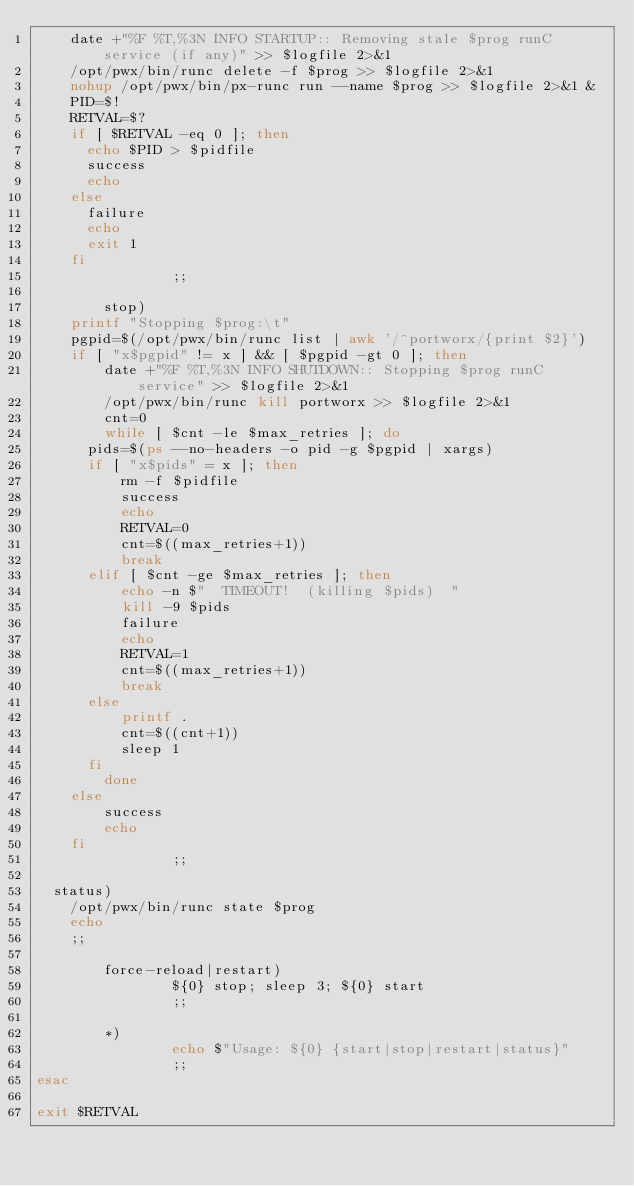Convert code to text. <code><loc_0><loc_0><loc_500><loc_500><_Bash_>		date +"%F %T,%3N INFO STARTUP:: Removing stale $prog runC service (if any)" >> $logfile 2>&1
		/opt/pwx/bin/runc delete -f $prog >> $logfile 2>&1
		nohup /opt/pwx/bin/px-runc run --name $prog >> $logfile 2>&1 &
		PID=$!
		RETVAL=$?
		if [ $RETVAL -eq 0 ]; then
			echo $PID > $pidfile
			success
			echo
		else
			failure
			echo
			exit 1
		fi
                ;;

        stop)
		printf "Stopping $prog:\t"
		pgpid=$(/opt/pwx/bin/runc list | awk '/^portworx/{print $2}')
		if [ "x$pgpid" != x ] && [ $pgpid -gt 0 ]; then
		    date +"%F %T,%3N INFO SHUTDOWN:: Stopping $prog runC service" >> $logfile 2>&1
		    /opt/pwx/bin/runc kill portworx >> $logfile 2>&1
		    cnt=0
		    while [ $cnt -le $max_retries ]; do
			pids=$(ps --no-headers -o pid -g $pgpid | xargs)
			if [ "x$pids" = x ]; then
			    rm -f $pidfile
			    success
			    echo
			    RETVAL=0
			    cnt=$((max_retries+1))
			    break
			elif [ $cnt -ge $max_retries ]; then
			    echo -n $"  TIMEOUT!  (killing $pids)  "
			    kill -9 $pids
			    failure
			    echo
			    RETVAL=1
			    cnt=$((max_retries+1))
			    break
			else
			    printf .
			    cnt=$((cnt+1))
			    sleep 1
			fi
		    done
		else
		    success
		    echo
		fi
                ;;

	status)
		/opt/pwx/bin/runc state $prog
		echo
		;;

        force-reload|restart)
                ${0} stop; sleep 3; ${0} start
                ;;

        *)
                echo $"Usage: ${0} {start|stop|restart|status}"
                ;;
esac

exit $RETVAL
</code> 